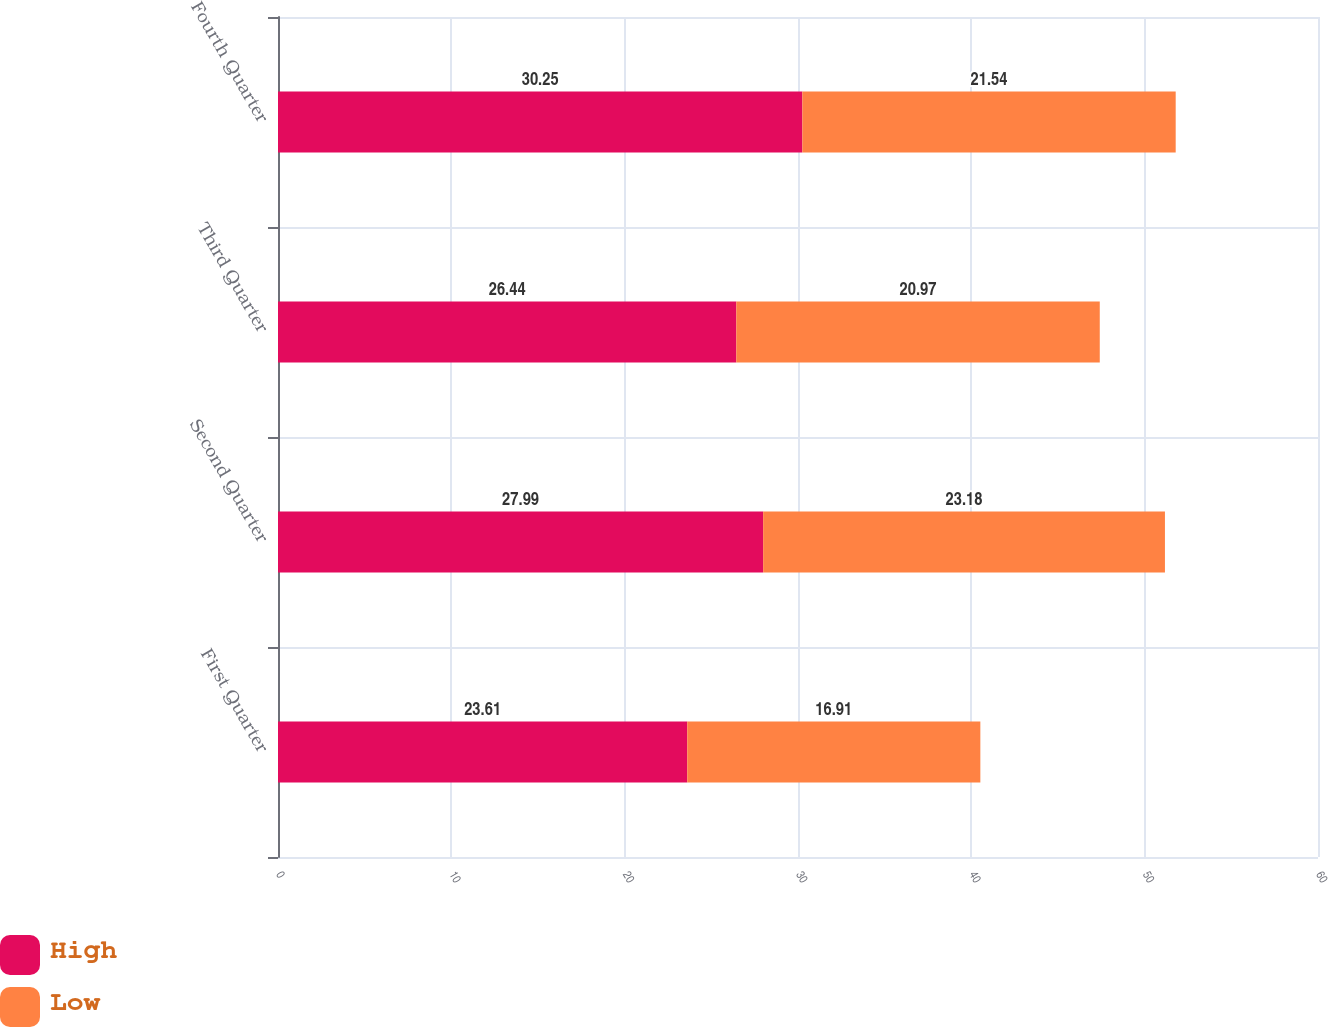Convert chart. <chart><loc_0><loc_0><loc_500><loc_500><stacked_bar_chart><ecel><fcel>First Quarter<fcel>Second Quarter<fcel>Third Quarter<fcel>Fourth Quarter<nl><fcel>High<fcel>23.61<fcel>27.99<fcel>26.44<fcel>30.25<nl><fcel>Low<fcel>16.91<fcel>23.18<fcel>20.97<fcel>21.54<nl></chart> 